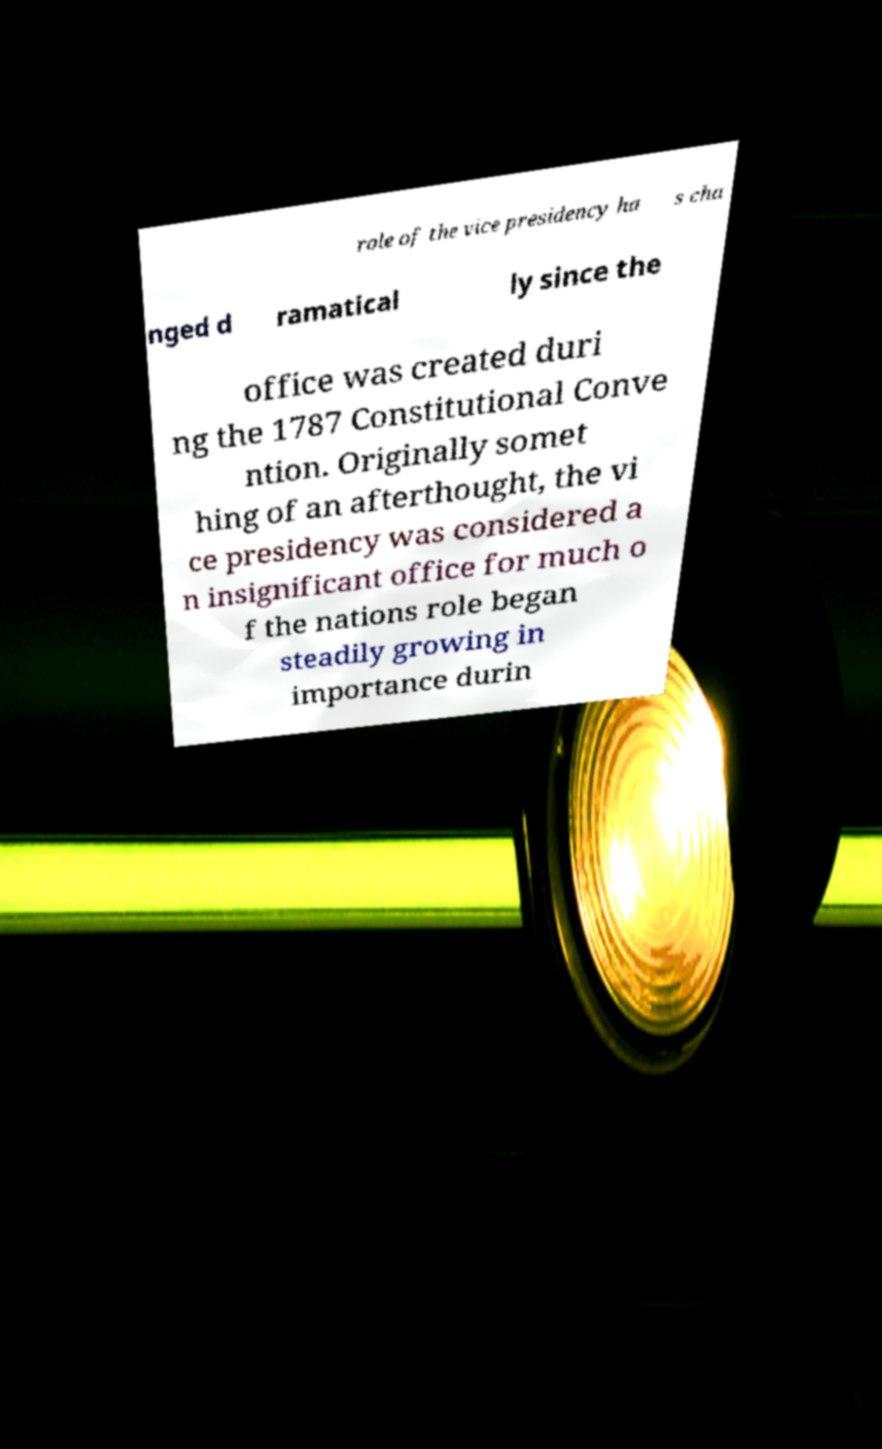For documentation purposes, I need the text within this image transcribed. Could you provide that? role of the vice presidency ha s cha nged d ramatical ly since the office was created duri ng the 1787 Constitutional Conve ntion. Originally somet hing of an afterthought, the vi ce presidency was considered a n insignificant office for much o f the nations role began steadily growing in importance durin 